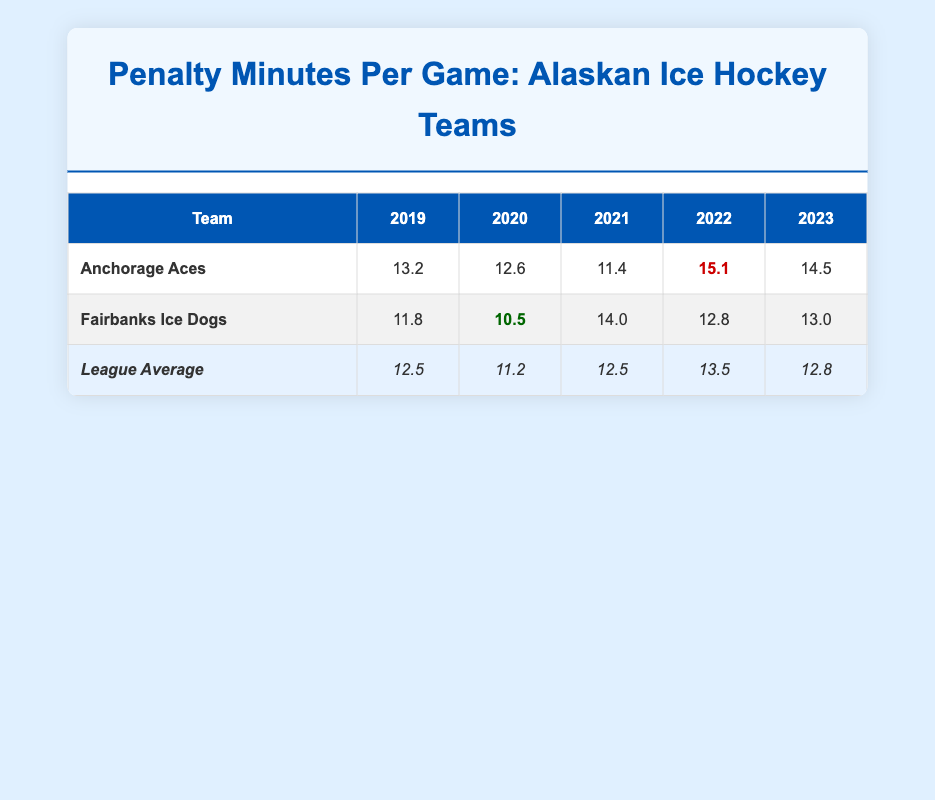What was the highest penalty minutes per game recorded by the Anchorage Aces? From the table, we can see that the Anchorage Aces recorded a penalty time of 15.1 in the 2022 season, which is marked as the highest value for that team.
Answer: 15.1 What were the penalty minutes per game for the Fairbanks Ice Dogs in 2020? The table shows that the Fairbanks Ice Dogs had penalty minutes per game of 10.5 in the 2020 season, which is listed directly under the respective category.
Answer: 10.5 Which team had the lowest penalty minutes per game in 2019? Looking at the table, the Fairbanks Ice Dogs had the lowest penalty minutes per game of 11.8 in 2019 compared to the Anchorage Aces' 13.2.
Answer: Fairbanks Ice Dogs What is the average penalty minutes per game for the Anchorage Aces over the five seasons? To find the average, we add the penalty minutes: (13.2 + 12.6 + 11.4 + 15.1 + 14.5) = 66.8, then divide by 5 seasons: 66.8 / 5 = 13.36.
Answer: 13.36 Did the Anchorage Aces ever have a penalty minutes per game average above the league average? Looking at the table data, it shows that in the seasons 2019 (13.2) and 2022 (15.1), the Anchorage Aces had averages above the league averages of 12.5 and 13.5, respectively. Therefore, it is true.
Answer: Yes What was the total penalty minutes per game difference between the Fairbanks Ice Dogs in 2021 and the league average for that same year? For the Fairbanks Ice Dogs in 2021, the penalty minutes were 14.0, while the league average was 12.5. The difference is 14.0 - 12.5 = 1.5.
Answer: 1.5 Which team had a consistently lower penalty minutes per game than the league average over the last three seasons? By analyzing the table, we find that the Fairbanks Ice Dogs were below the league average in the 2021 (14.0) and 2022 (12.8) seasons, but above in the other seasons; hence, they do not consistently show this trend. On the other hand, the Anchorage Aces had values above the league average in 2021 and 2022, indicating inconsistency. Thus, neither team consistently had lower than the league average.
Answer: No team Was there a season when the penalty minutes for both teams were below the league average? Referring to the data, in the 2020 season, both teams (Anchorage Aces: 12.6, Fairbanks Ice Dogs: 10.5) were below the league average of 11.2, confirming this as a true statement.
Answer: Yes What has been the trend in penalty minutes for the Anchorage Aces from 2019 to 2023? Analyzing the table shows that the penalty minutes for the Anchorage Aces decreased from 13.2 in 2019 to 11.4 in 2021, then increased to 15.1 in 2022 and slightly decreased to 14.5 in 2023. Thus, the trend depicts a decline followed by an increase.
Answer: Decline then increase 